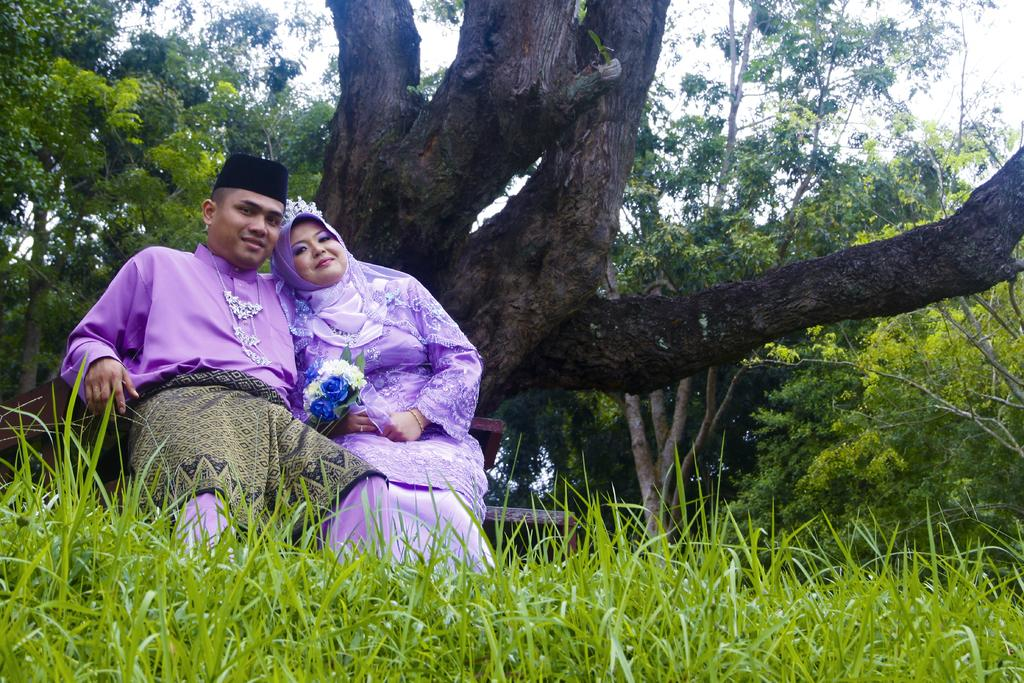Who can be seen in the image? There is a man and a woman in the image. What are the man and woman doing in the image? Both the man and woman are sitting on a bench. What is in front of the bench? There is grass in front of the bench. What can be seen in the background of the image? There are trees in the background of the image. What type of minister is playing with the trees in the image? There is no minister or any indication of playing with trees in the image. 